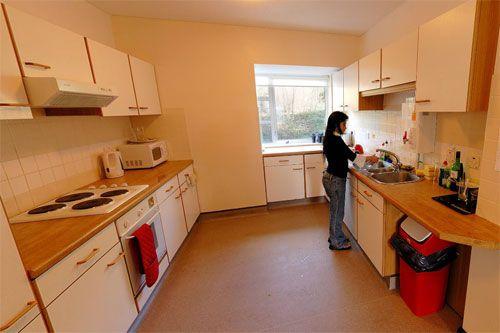What color has the owner used to accessorize the kitchen?
Write a very short answer. Red. What color is the trash can?
Be succinct. Red. Is the kitchen clean?
Quick response, please. Yes. 